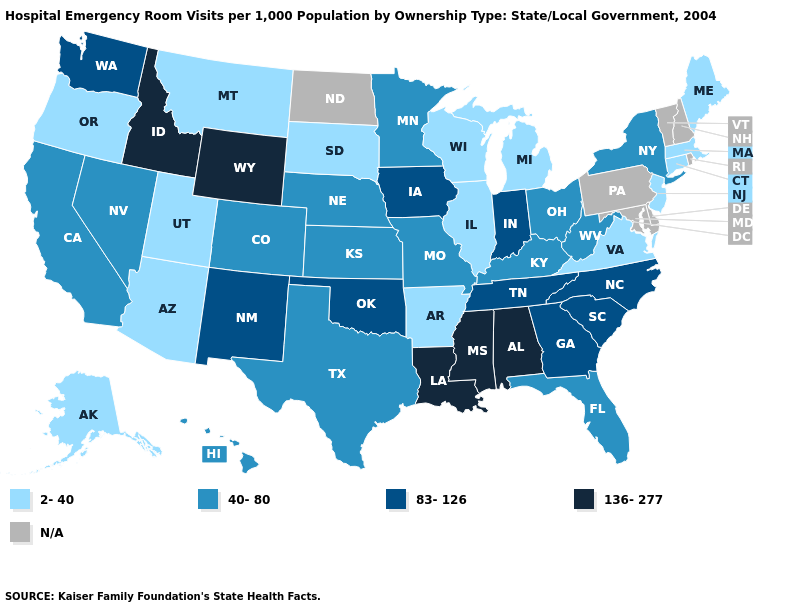Among the states that border Ohio , does West Virginia have the lowest value?
Keep it brief. No. Among the states that border West Virginia , does Virginia have the highest value?
Write a very short answer. No. What is the value of Alabama?
Keep it brief. 136-277. Name the states that have a value in the range 83-126?
Write a very short answer. Georgia, Indiana, Iowa, New Mexico, North Carolina, Oklahoma, South Carolina, Tennessee, Washington. What is the value of South Carolina?
Write a very short answer. 83-126. How many symbols are there in the legend?
Keep it brief. 5. What is the value of Arkansas?
Keep it brief. 2-40. Name the states that have a value in the range 40-80?
Concise answer only. California, Colorado, Florida, Hawaii, Kansas, Kentucky, Minnesota, Missouri, Nebraska, Nevada, New York, Ohio, Texas, West Virginia. What is the value of Idaho?
Be succinct. 136-277. What is the value of Virginia?
Write a very short answer. 2-40. Does the first symbol in the legend represent the smallest category?
Short answer required. Yes. Which states have the lowest value in the Northeast?
Be succinct. Connecticut, Maine, Massachusetts, New Jersey. Which states hav the highest value in the West?
Quick response, please. Idaho, Wyoming. What is the value of Montana?
Quick response, please. 2-40. 